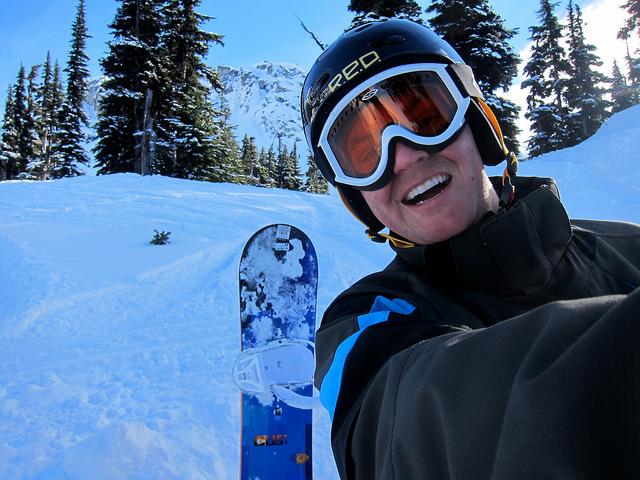What is on this persons head?
Short answer required. Helmet. Is the sky cloudy?
Be succinct. No. Where is the men's snowboard?
Answer briefly. In snow. 